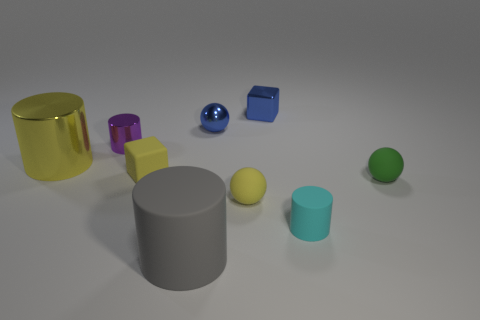Subtract all matte balls. How many balls are left? 1 Add 1 tiny yellow matte balls. How many objects exist? 10 Subtract all blue blocks. How many blocks are left? 1 Add 9 blue balls. How many blue balls exist? 10 Subtract 0 cyan balls. How many objects are left? 9 Subtract all cylinders. How many objects are left? 5 Subtract 2 balls. How many balls are left? 1 Subtract all gray blocks. Subtract all brown spheres. How many blocks are left? 2 Subtract all gray cubes. How many blue balls are left? 1 Subtract all rubber spheres. Subtract all tiny yellow rubber things. How many objects are left? 5 